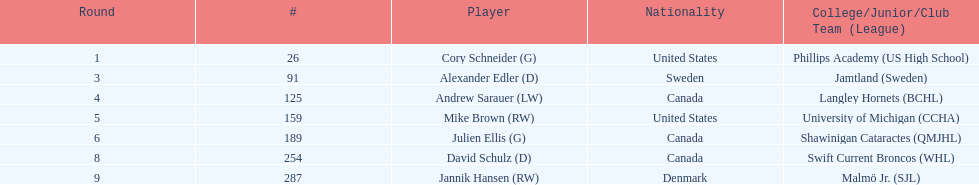How many players have canada mentioned as their nationality? 3. 